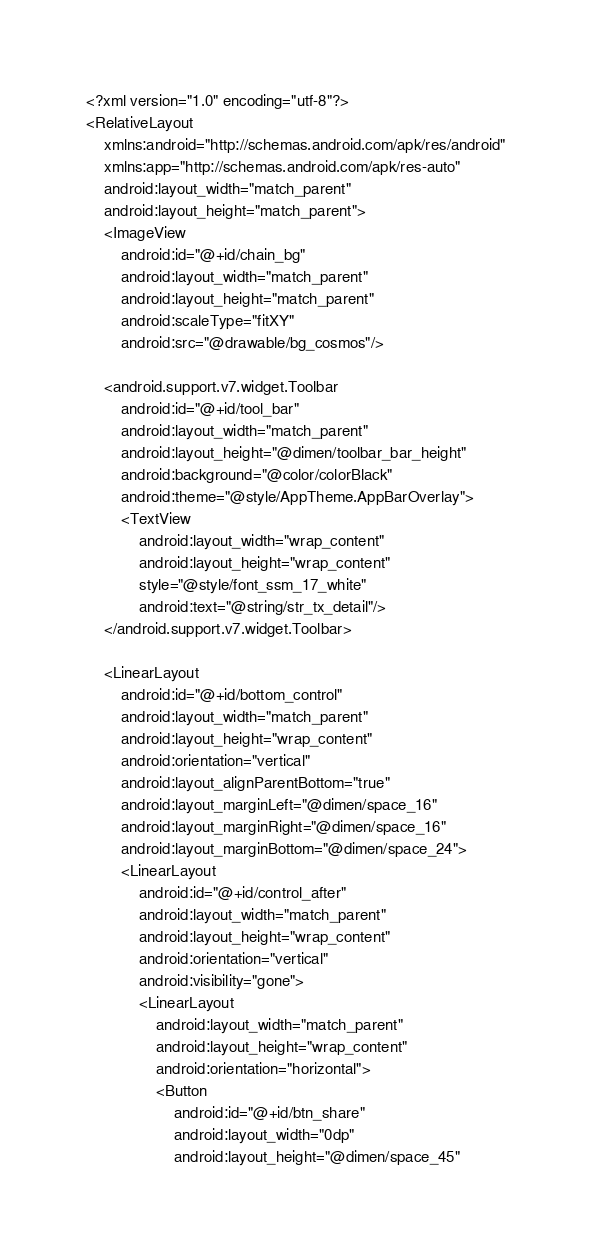<code> <loc_0><loc_0><loc_500><loc_500><_XML_><?xml version="1.0" encoding="utf-8"?>
<RelativeLayout
    xmlns:android="http://schemas.android.com/apk/res/android"
    xmlns:app="http://schemas.android.com/apk/res-auto"
    android:layout_width="match_parent"
    android:layout_height="match_parent">
    <ImageView
        android:id="@+id/chain_bg"
        android:layout_width="match_parent"
        android:layout_height="match_parent"
        android:scaleType="fitXY"
        android:src="@drawable/bg_cosmos"/>

    <android.support.v7.widget.Toolbar
        android:id="@+id/tool_bar"
        android:layout_width="match_parent"
        android:layout_height="@dimen/toolbar_bar_height"
        android:background="@color/colorBlack"
        android:theme="@style/AppTheme.AppBarOverlay">
        <TextView
            android:layout_width="wrap_content"
            android:layout_height="wrap_content"
            style="@style/font_ssm_17_white"
            android:text="@string/str_tx_detail"/>
    </android.support.v7.widget.Toolbar>

    <LinearLayout
        android:id="@+id/bottom_control"
        android:layout_width="match_parent"
        android:layout_height="wrap_content"
        android:orientation="vertical"
        android:layout_alignParentBottom="true"
        android:layout_marginLeft="@dimen/space_16"
        android:layout_marginRight="@dimen/space_16"
        android:layout_marginBottom="@dimen/space_24">
        <LinearLayout
            android:id="@+id/control_after"
            android:layout_width="match_parent"
            android:layout_height="wrap_content"
            android:orientation="vertical"
            android:visibility="gone">
            <LinearLayout
                android:layout_width="match_parent"
                android:layout_height="wrap_content"
                android:orientation="horizontal">
                <Button
                    android:id="@+id/btn_share"
                    android:layout_width="0dp"
                    android:layout_height="@dimen/space_45"</code> 